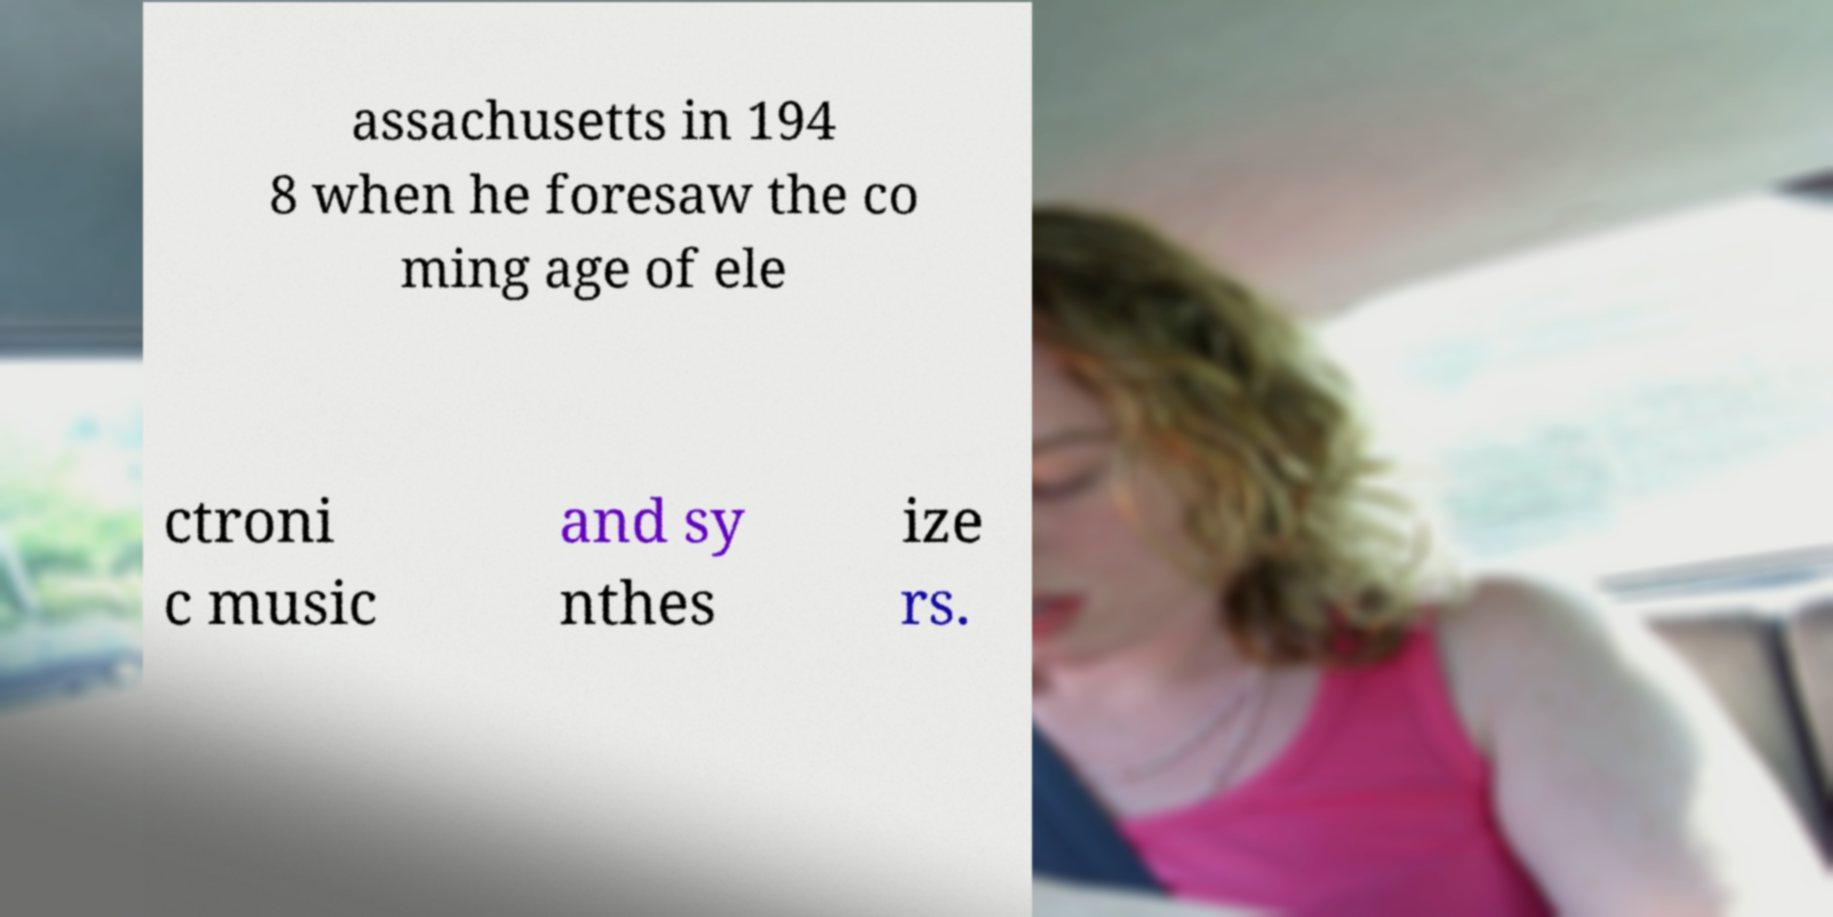For documentation purposes, I need the text within this image transcribed. Could you provide that? assachusetts in 194 8 when he foresaw the co ming age of ele ctroni c music and sy nthes ize rs. 